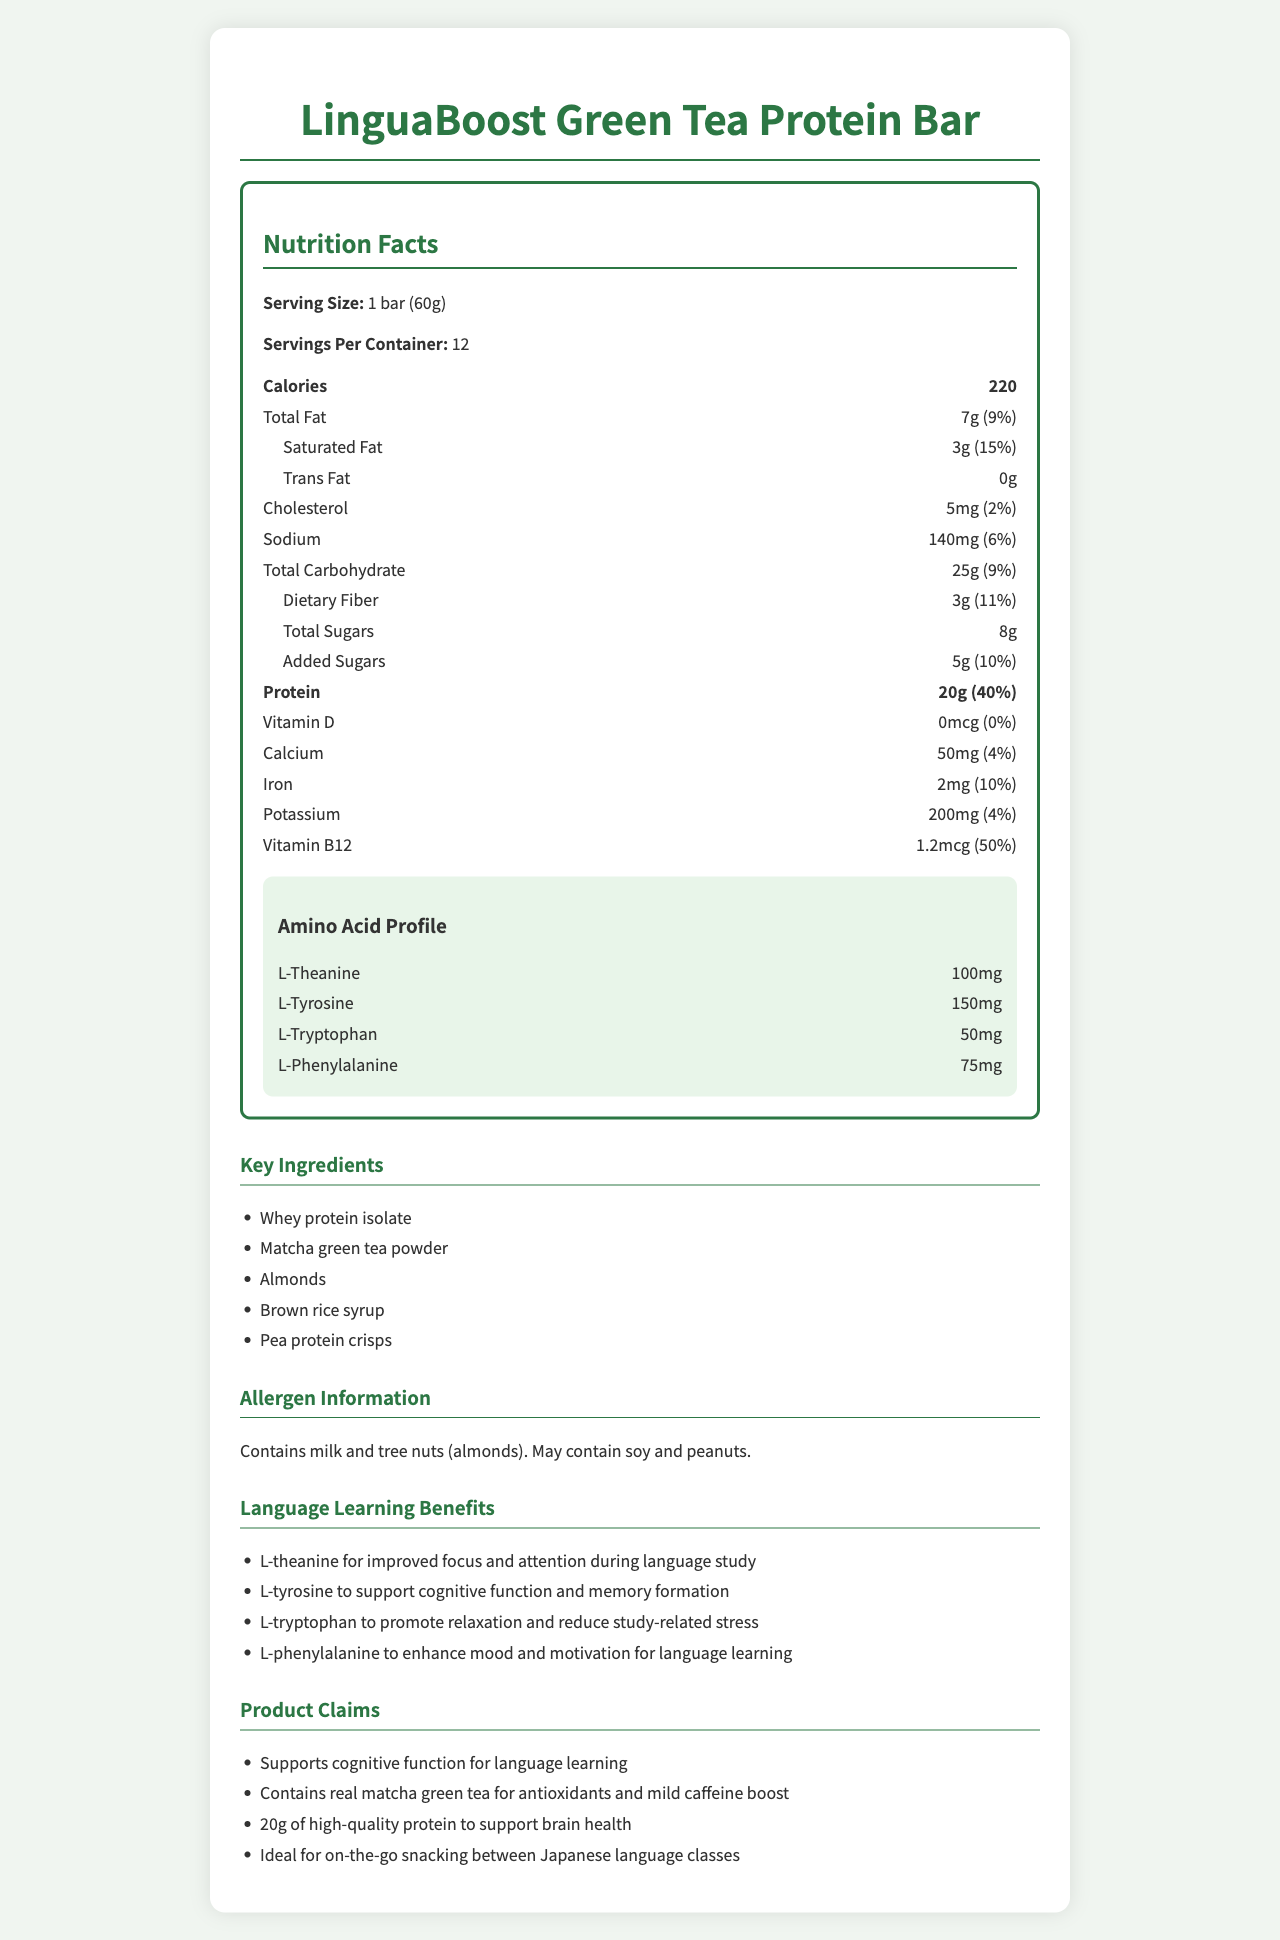what is the serving size of the LinguaBoost Green Tea Protein Bar? The serving size is mentioned at the beginning of the Nutrition Facts section as "Serving Size: 1 bar (60g)".
Answer: 1 bar (60g) how many calories are in one serving of the LinguaBoost Green Tea Protein Bar? The document lists the calorie count as 220 under the Nutrition Facts section.
Answer: 220 how much protein does one bar contain? Protein content is specified as "20g" in the Nutrition Facts section.
Answer: 20g how much dietary fiber is there in one bar? The dietary fiber content is listed as "3g" in the Nutrition Facts section.
Answer: 3g what is the daily value percentage of vitamin B12 offered by one bar? The daily value percentage is shown as "50%" next to the vitamin B12 amount in the Nutrition Facts section.
Answer: 50% which of the following amino acids are listed in the document? A. L-theanine B. L-arginine C. L-leucine D. L-serine The listed amino acids include L-theanine, L-tyrosine, L-tryptophan, and L-phenylalanine. L-arginine, L-leucine, and L-serine are not part of the amino acid profile in the document.
Answer: A. L-theanine how many servings are in one container of the LinguaBoost Green Tea Protein Bar? 1. 6 2. 8 3. 10 4. 12 The document lists "Servings Per Container: 12" under the Nutrition Facts section.
Answer: 4. 12 does the protein bar contain any peanuts? The allergen information section mentions that the bar "May contain soy and peanuts."
Answer: May contain is there any cholesterol in the LinguaBoost Green Tea Protein Bar? The document states "Cholesterol: 5mg (2%)" under the Nutrition Facts section.
Answer: Yes briefly summarize the key nutritional benefits of the LinguaBoost Green Tea Protein Bar for language learning. The document highlights the benefits of these amino acids specifically for aiding cognitive functions that are beneficial for language learning.
Answer: The LinguaBoost Green Tea Protein Bar supports cognitive function with ingredients like L-theanine for improved focus, L-tyrosine for cognitive support, L-tryptophan for stress reduction, and L-phenylalanine for enhanced mood and motivation. who is the primary target audience for this product? The document does not explicitly specify the primary target audience besides highlighting the language learning benefits, but it does not give detailed demographic information.
Answer: Cannot be determined 